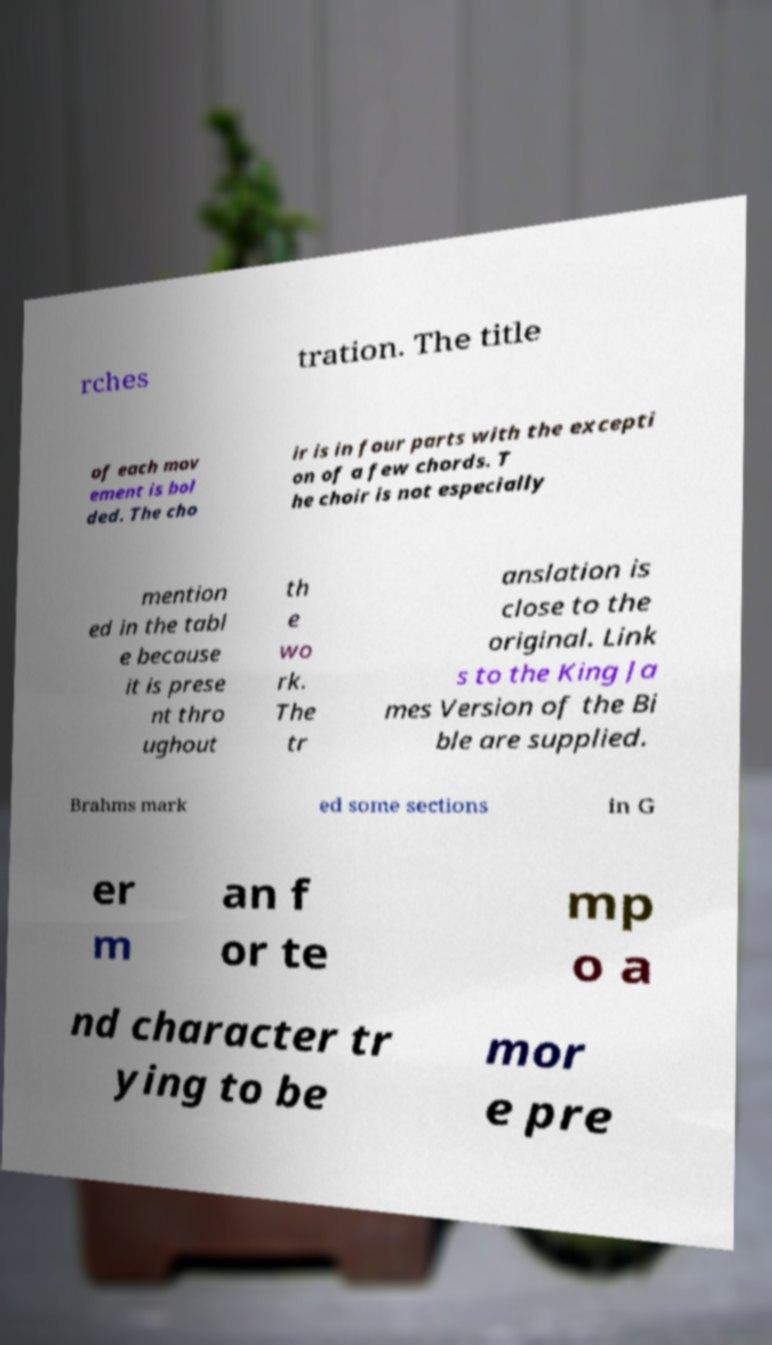Please read and relay the text visible in this image. What does it say? rches tration. The title of each mov ement is bol ded. The cho ir is in four parts with the excepti on of a few chords. T he choir is not especially mention ed in the tabl e because it is prese nt thro ughout th e wo rk. The tr anslation is close to the original. Link s to the King Ja mes Version of the Bi ble are supplied. Brahms mark ed some sections in G er m an f or te mp o a nd character tr ying to be mor e pre 